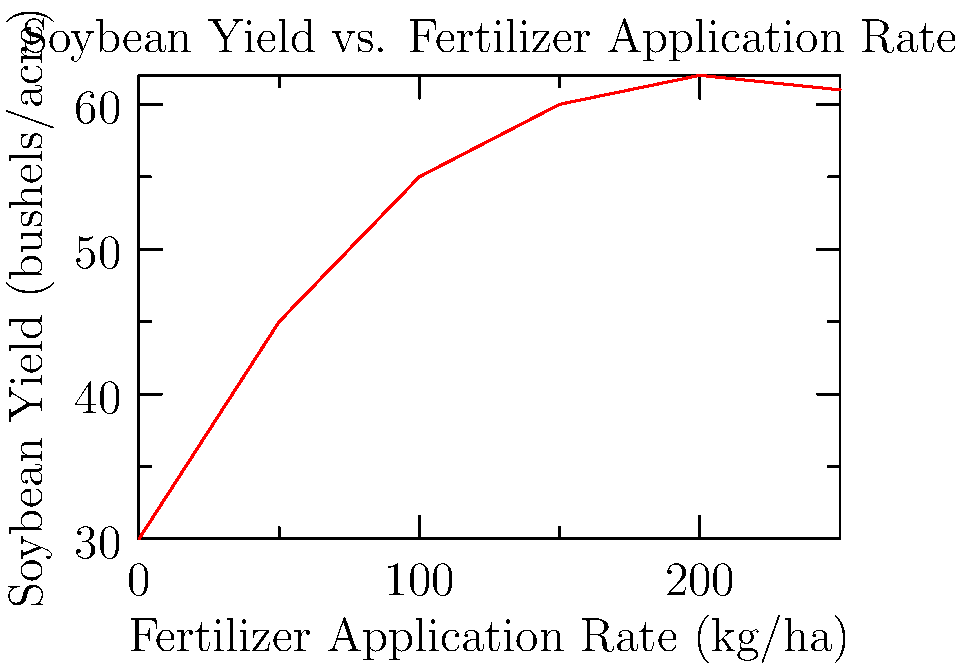Based on the graph, at what fertilizer application rate does the soybean yield appear to reach its maximum? What strategy would you recommend to optimize fertilizer use while maintaining high yields? To answer this question, we need to analyze the graph step-by-step:

1. Observe the overall trend: The soybean yield increases with fertilizer application rate, but the rate of increase slows down at higher application rates.

2. Identify the peak: The yield appears to reach its maximum at around 200 kg/ha of fertilizer. After this point, the yield slightly decreases.

3. Analyze the curve:
   - From 0 to 100 kg/ha: Steep increase in yield
   - From 100 to 200 kg/ha: Slower increase in yield
   - After 200 kg/ha: Slight decrease in yield

4. Optimize fertilizer use:
   - The maximum yield is achieved at 200 kg/ha
   - However, the yield increase is minimal between 150 and 200 kg/ha
   - Applying fertilizer beyond 200 kg/ha leads to diminishing returns and potential yield decrease

5. Strategy recommendation:
   - Apply fertilizer at a rate between 150-200 kg/ha
   - This range optimizes yield while avoiding excessive fertilizer use
   - Consider using precision agriculture techniques to apply variable rates based on soil conditions and plant needs

6. Additional considerations:
   - Monitor soil nutrient levels regularly
   - Implement crop rotation to maintain soil health
   - Consider using cover crops to improve soil structure and nutrient content
Answer: 200 kg/ha; apply 150-200 kg/ha for optimal yield and efficiency. 